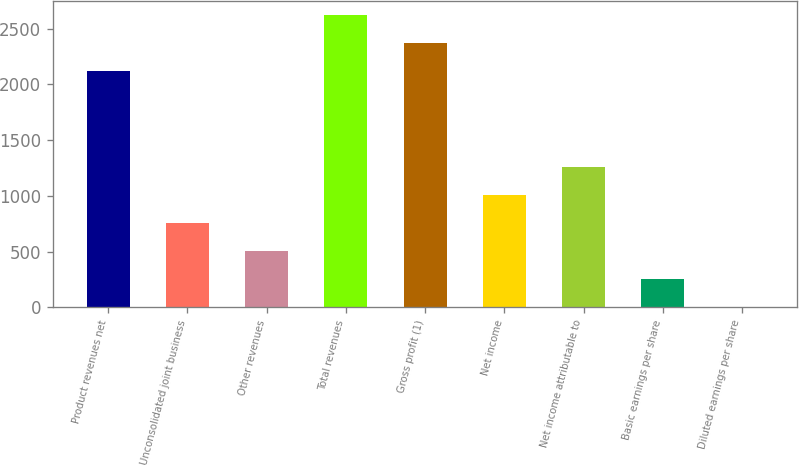Convert chart. <chart><loc_0><loc_0><loc_500><loc_500><bar_chart><fcel>Product revenues net<fcel>Unconsolidated joint business<fcel>Other revenues<fcel>Total revenues<fcel>Gross profit (1)<fcel>Net income<fcel>Net income attributable to<fcel>Basic earnings per share<fcel>Diluted earnings per share<nl><fcel>2117.3<fcel>755.96<fcel>505.18<fcel>2618.86<fcel>2368.08<fcel>1006.74<fcel>1257.52<fcel>254.4<fcel>3.62<nl></chart> 